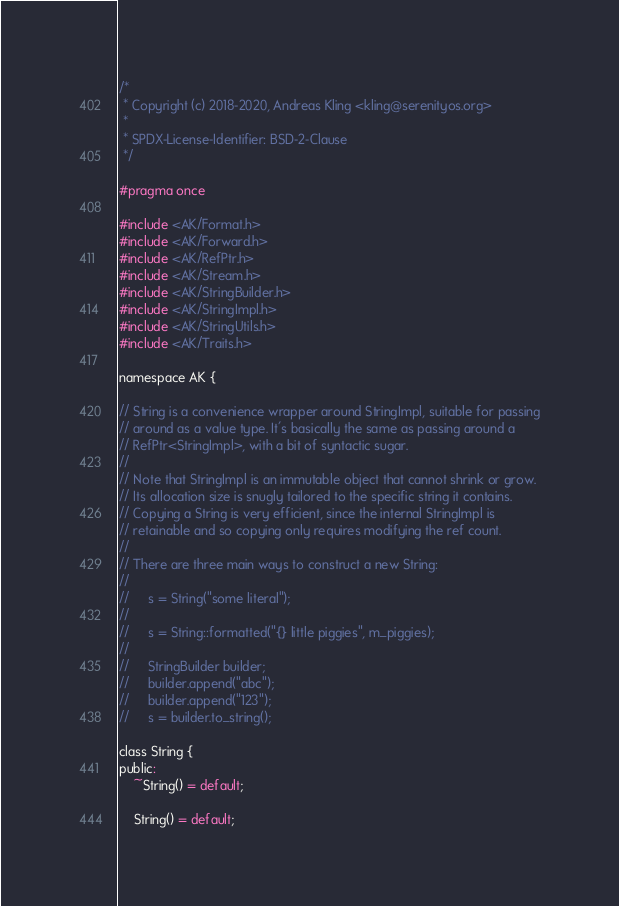<code> <loc_0><loc_0><loc_500><loc_500><_C_>/*
 * Copyright (c) 2018-2020, Andreas Kling <kling@serenityos.org>
 *
 * SPDX-License-Identifier: BSD-2-Clause
 */

#pragma once

#include <AK/Format.h>
#include <AK/Forward.h>
#include <AK/RefPtr.h>
#include <AK/Stream.h>
#include <AK/StringBuilder.h>
#include <AK/StringImpl.h>
#include <AK/StringUtils.h>
#include <AK/Traits.h>

namespace AK {

// String is a convenience wrapper around StringImpl, suitable for passing
// around as a value type. It's basically the same as passing around a
// RefPtr<StringImpl>, with a bit of syntactic sugar.
//
// Note that StringImpl is an immutable object that cannot shrink or grow.
// Its allocation size is snugly tailored to the specific string it contains.
// Copying a String is very efficient, since the internal StringImpl is
// retainable and so copying only requires modifying the ref count.
//
// There are three main ways to construct a new String:
//
//     s = String("some literal");
//
//     s = String::formatted("{} little piggies", m_piggies);
//
//     StringBuilder builder;
//     builder.append("abc");
//     builder.append("123");
//     s = builder.to_string();

class String {
public:
    ~String() = default;

    String() = default;
</code> 